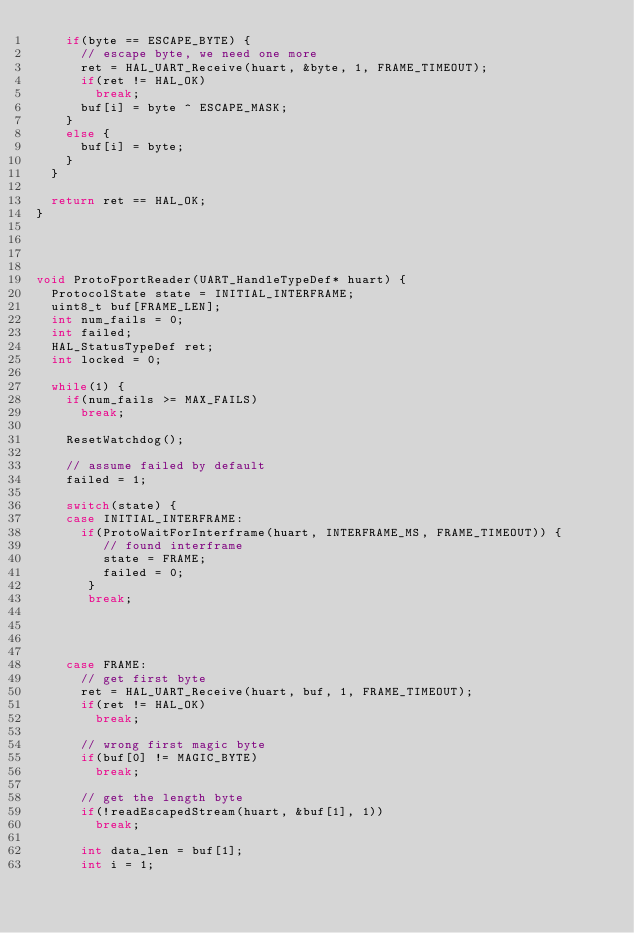Convert code to text. <code><loc_0><loc_0><loc_500><loc_500><_C_>    if(byte == ESCAPE_BYTE) {
      // escape byte, we need one more
      ret = HAL_UART_Receive(huart, &byte, 1, FRAME_TIMEOUT);
      if(ret != HAL_OK)
        break;
      buf[i] = byte ^ ESCAPE_MASK;
    }
    else {
      buf[i] = byte;
    }
  }

  return ret == HAL_OK;
}




void ProtoFportReader(UART_HandleTypeDef* huart) {
  ProtocolState state = INITIAL_INTERFRAME;
  uint8_t buf[FRAME_LEN];
  int num_fails = 0;
  int failed;
  HAL_StatusTypeDef ret;
  int locked = 0;

  while(1) {
    if(num_fails >= MAX_FAILS)
      break;

    ResetWatchdog();

    // assume failed by default
    failed = 1;

    switch(state) {
    case INITIAL_INTERFRAME:
      if(ProtoWaitForInterframe(huart, INTERFRAME_MS, FRAME_TIMEOUT)) {
         // found interframe
         state = FRAME;
         failed = 0;
       }
       break;




    case FRAME:
      // get first byte
      ret = HAL_UART_Receive(huart, buf, 1, FRAME_TIMEOUT);
      if(ret != HAL_OK)
        break;

      // wrong first magic byte
      if(buf[0] != MAGIC_BYTE)
        break;

      // get the length byte
      if(!readEscapedStream(huart, &buf[1], 1))
        break;

      int data_len = buf[1];
      int i = 1;</code> 